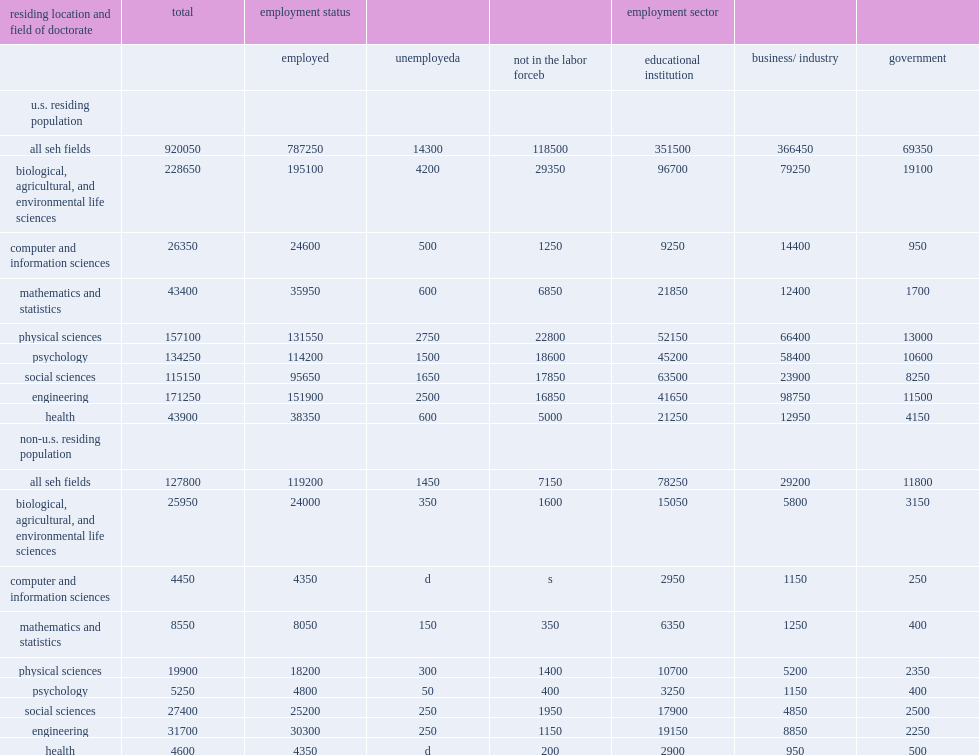Parse the table in full. {'header': ['residing location and field of doctorate', 'total', 'employment status', '', '', 'employment sector', '', ''], 'rows': [['', '', 'employed', 'unemployeda', 'not in the labor forceb', 'educational institution', 'business/ industry', 'government'], ['u.s. residing population', '', '', '', '', '', '', ''], ['all seh fields', '920050', '787250', '14300', '118500', '351500', '366450', '69350'], ['biological, agricultural, and environmental life sciences', '228650', '195100', '4200', '29350', '96700', '79250', '19100'], ['computer and information sciences', '26350', '24600', '500', '1250', '9250', '14400', '950'], ['mathematics and statistics', '43400', '35950', '600', '6850', '21850', '12400', '1700'], ['physical sciences', '157100', '131550', '2750', '22800', '52150', '66400', '13000'], ['psychology', '134250', '114200', '1500', '18600', '45200', '58400', '10600'], ['social sciences', '115150', '95650', '1650', '17850', '63500', '23900', '8250'], ['engineering', '171250', '151900', '2500', '16850', '41650', '98750', '11500'], ['health', '43900', '38350', '600', '5000', '21250', '12950', '4150'], ['non-u.s. residing population', '', '', '', '', '', '', ''], ['all seh fields', '127800', '119200', '1450', '7150', '78250', '29200', '11800'], ['biological, agricultural, and environmental life sciences', '25950', '24000', '350', '1600', '15050', '5800', '3150'], ['computer and information sciences', '4450', '4350', 'd', 's', '2950', '1150', '250'], ['mathematics and statistics', '8550', '8050', '150', '350', '6350', '1250', '400'], ['physical sciences', '19900', '18200', '300', '1400', '10700', '5200', '2350'], ['psychology', '5250', '4800', '50', '400', '3250', '1150', '400'], ['social sciences', '27400', '25200', '250', '1950', '17900', '4850', '2500'], ['engineering', '31700', '30300', '250', '1150', '19150', '8850', '2250'], ['health', '4600', '4350', 'd', '200', '2900', '950', '500']]} What was the number of the seh doctorate holders were residing in the united states? 920050.0. What was the number of the seh doctorate holders were residing in a foreign country? 127800.0. In 2015, how many individuals worldwide held u.s. research doctoral degrees in science, engineering, and health (seh) fields? 1047850. Among the seh doctoral degree holders in the united states in 2015, how many percent were in the labor force? 0.871203. Of the non-u.s. residing population, how many percent were in the labor force? 0.944053. Of the non-u.s. residing population, 94% were in the labor force, what was an unemployment rate? 0.011346. 